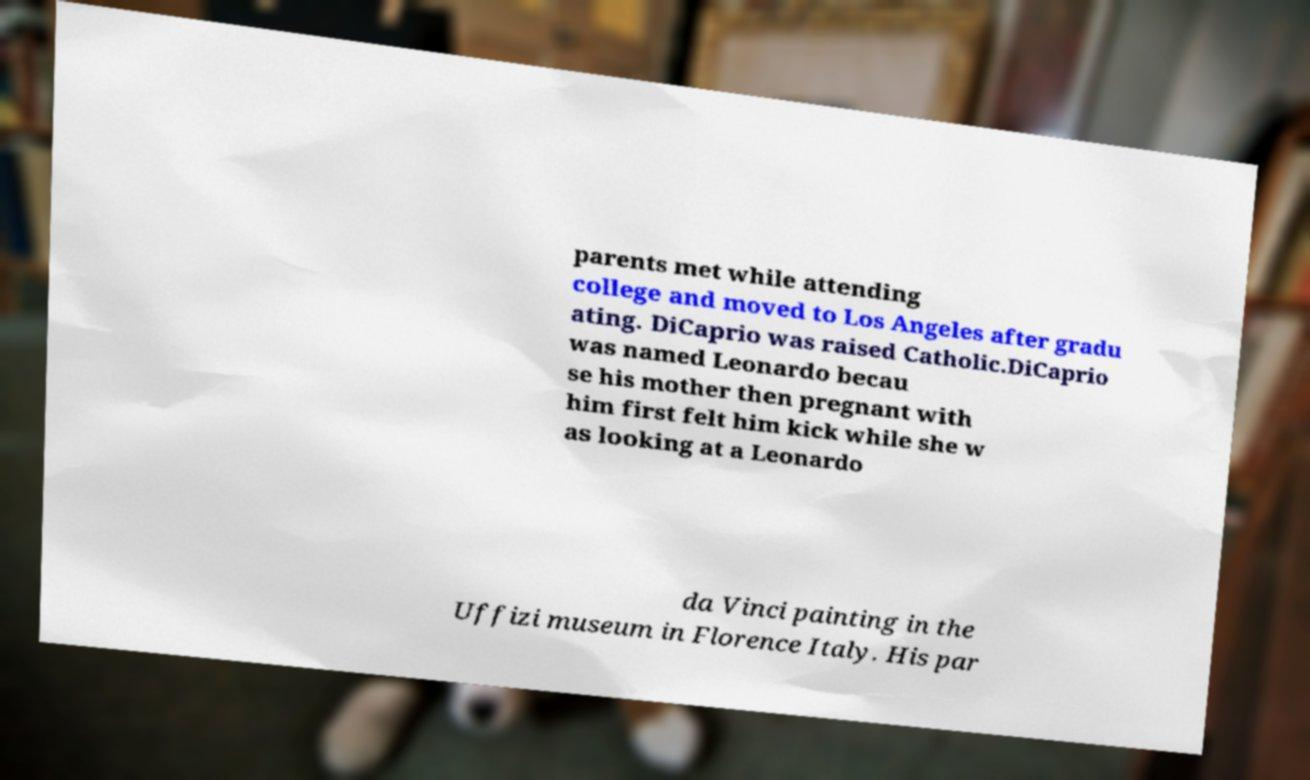Can you accurately transcribe the text from the provided image for me? parents met while attending college and moved to Los Angeles after gradu ating. DiCaprio was raised Catholic.DiCaprio was named Leonardo becau se his mother then pregnant with him first felt him kick while she w as looking at a Leonardo da Vinci painting in the Uffizi museum in Florence Italy. His par 